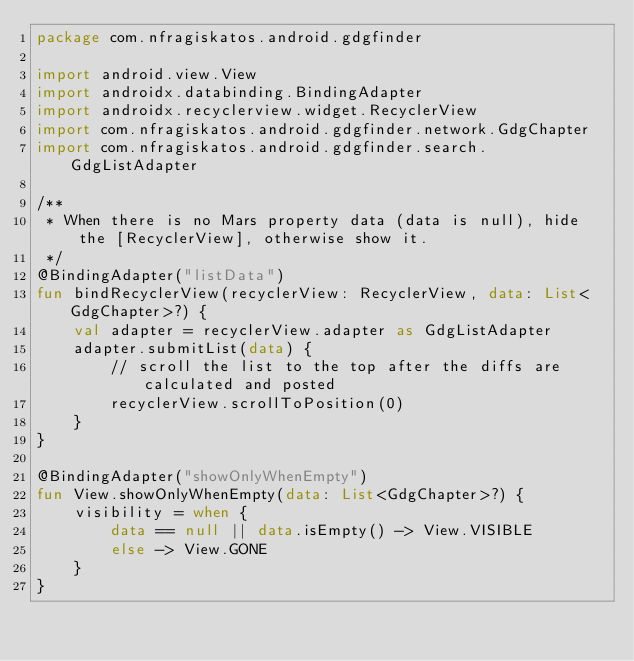<code> <loc_0><loc_0><loc_500><loc_500><_Kotlin_>package com.nfragiskatos.android.gdgfinder

import android.view.View
import androidx.databinding.BindingAdapter
import androidx.recyclerview.widget.RecyclerView
import com.nfragiskatos.android.gdgfinder.network.GdgChapter
import com.nfragiskatos.android.gdgfinder.search.GdgListAdapter

/**
 * When there is no Mars property data (data is null), hide the [RecyclerView], otherwise show it.
 */
@BindingAdapter("listData")
fun bindRecyclerView(recyclerView: RecyclerView, data: List<GdgChapter>?) {
    val adapter = recyclerView.adapter as GdgListAdapter
    adapter.submitList(data) {
        // scroll the list to the top after the diffs are calculated and posted
        recyclerView.scrollToPosition(0)
    }
}

@BindingAdapter("showOnlyWhenEmpty")
fun View.showOnlyWhenEmpty(data: List<GdgChapter>?) {
    visibility = when {
        data == null || data.isEmpty() -> View.VISIBLE
        else -> View.GONE
    }
}</code> 